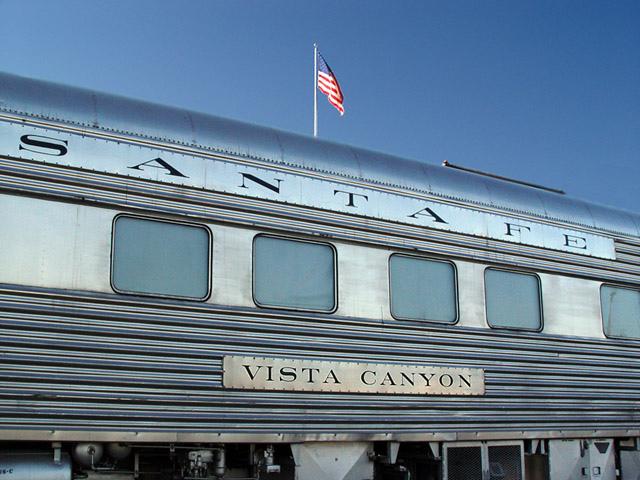What city is this?
Write a very short answer. Santa fe. What the train say?
Be succinct. Vista canyon. What portion of a public transportation vehicle does this resemble?
Keep it brief. Train. 